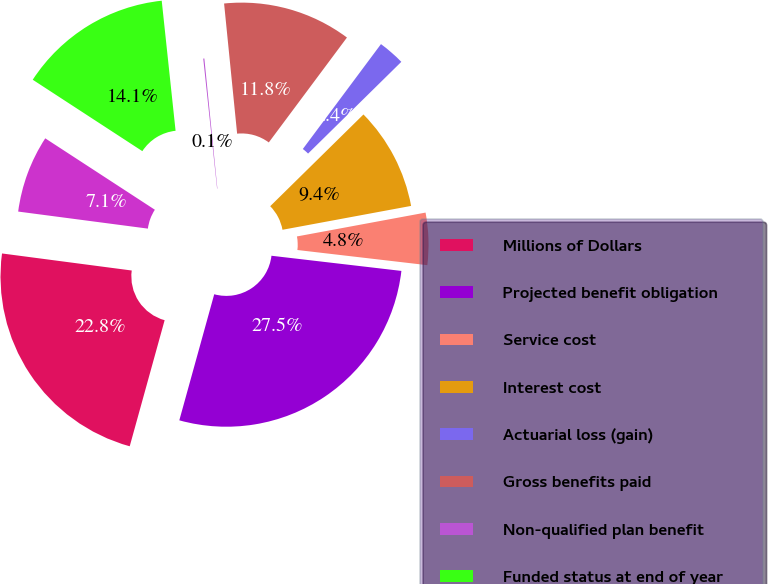Convert chart. <chart><loc_0><loc_0><loc_500><loc_500><pie_chart><fcel>Millions of Dollars<fcel>Projected benefit obligation<fcel>Service cost<fcel>Interest cost<fcel>Actuarial loss (gain)<fcel>Gross benefits paid<fcel>Non-qualified plan benefit<fcel>Funded status at end of year<fcel>Net amounts recognized at end<nl><fcel>22.78%<fcel>27.45%<fcel>4.77%<fcel>9.45%<fcel>2.44%<fcel>11.78%<fcel>0.1%<fcel>14.12%<fcel>7.11%<nl></chart> 